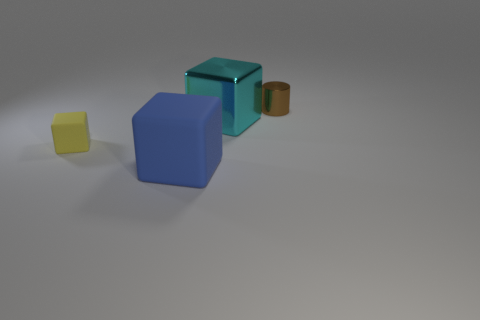The tiny metallic thing is what color?
Your answer should be very brief. Brown. Is the small cylinder the same color as the small block?
Offer a very short reply. No. Do the tiny thing that is to the left of the large metal thing and the big thing that is behind the yellow block have the same material?
Keep it short and to the point. No. What is the material of the other tiny object that is the same shape as the blue object?
Your answer should be very brief. Rubber. Does the tiny block have the same material as the small brown thing?
Make the answer very short. No. The thing that is on the left side of the matte block that is in front of the small rubber block is what color?
Ensure brevity in your answer.  Yellow. What size is the block that is made of the same material as the yellow thing?
Your answer should be very brief. Large. How many other large blue things have the same shape as the big blue thing?
Offer a very short reply. 0. How many things are either metal objects behind the large cyan object or tiny shiny cylinders that are behind the tiny yellow rubber cube?
Make the answer very short. 1. There is a metal thing that is behind the cyan metallic thing; how many blue rubber things are behind it?
Your answer should be compact. 0. 